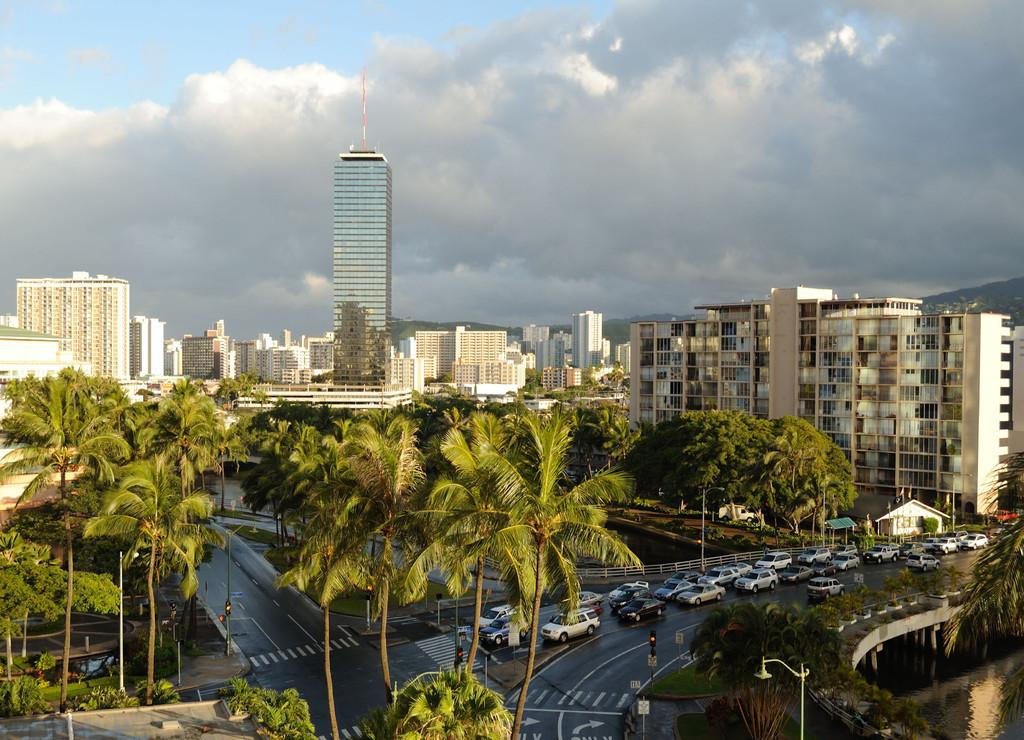What type of view is provided in the image? The image is an aerial view. What natural elements can be seen in the image? There are trees and a hill visible in the image. What man-made structures are present in the image? There is a road, traffic signals, vehicles, a bridge, a tower, and a window visible in the image. What is the condition of the sky in the image? The sky is visible in the image, and there are clouds present. What body of water can be seen in the image? There is water visible in the image. What type of reward is being given to the property owner in the image? There is no reward being given to a property owner in the image, as the image does not depict any specific event or interaction involving a property owner. 